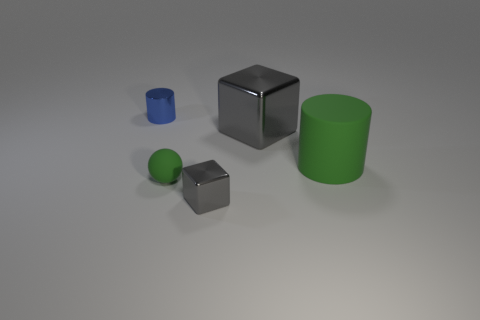Subtract all balls. How many objects are left? 4 Subtract 1 balls. How many balls are left? 0 Add 4 blue objects. How many objects exist? 9 Subtract all blue blocks. Subtract all red balls. How many blocks are left? 2 Subtract all cyan spheres. How many green cylinders are left? 1 Subtract all big cyan objects. Subtract all blue metallic objects. How many objects are left? 4 Add 5 big green cylinders. How many big green cylinders are left? 6 Add 5 large green things. How many large green things exist? 6 Subtract 0 yellow blocks. How many objects are left? 5 